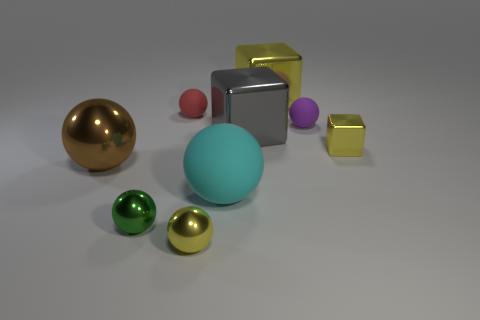Can you guess the size of the room where these objects are placed? It's challenging to estimate the size of the room since there are no reference points such as furniture or architecture. However, the shadows and the scale of the objects relative to one another may imply a moderately sized space, perhaps similar to a small studio or an intimate exhibition area. 